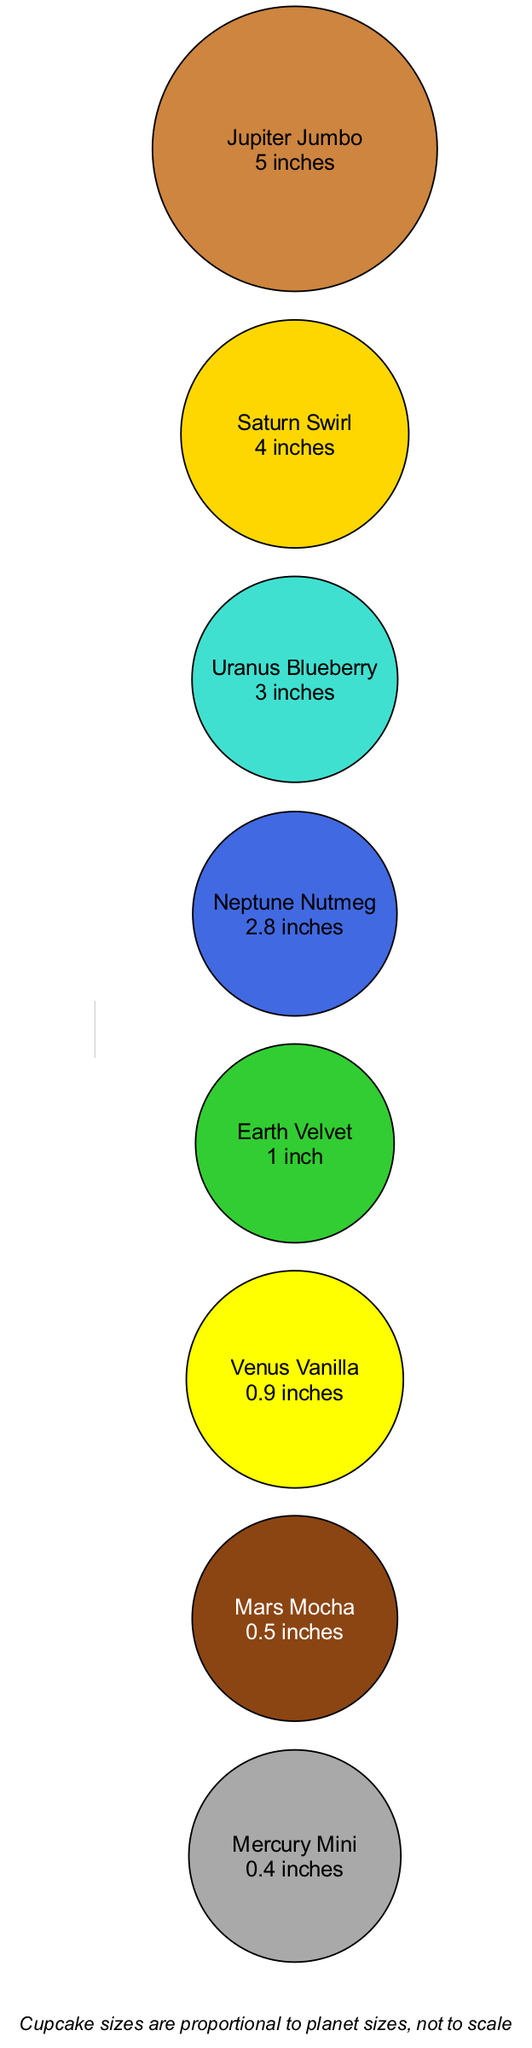What is the size of the largest cupcake? The largest cupcake is represented by "Jupiter Jumbo", which has a size of "5 inches" as stated in the diagram.
Answer: 5 inches Which cupcake has the blue frosting? The cupcake with blue frosting is "Uranus Blueberry", as described in the element details of the diagram.
Answer: Uranus Blueberry How many cupcakes are described in the diagram? Counting the elements listed in the diagram, there are a total of 8 different cupcakes, each representing a planet in the solar system.
Answer: 8 Which cupcake has the smallest size? The size of the smallest cupcake is "Mercury Mini" at "0.4 inches", making it the least in size amongst all the cupcakes presented in the diagram.
Answer: Mercury Mini What color is the "Saturn Swirl" cupcake? The "Saturn Swirl" cupcake is described with a vanilla flavor and has ring-shaped icing, which is indicative of the flavors represented.
Answer: Vanilla Which cupcake represents the third largest planet? The third largest cupcake is "Uranus Blueberry," which is sized at "3 inches". Upon sorting by size, it falls in the third position.
Answer: Uranus Blueberry Which planet is associated with the reddish-brown cupcake? The reddish-brown cupcake is associated with "Mars Mocha," as indicated in its description in the data.
Answer: Mars Mocha What is the average size of all cupcakes in the diagram? To find the average size, we sum all the sizes: 5 + 4 + 3 + 2.8 + 1 + 0.9 + 0.5 + 0.4 = 18.6 inches and divide by 8 cupcakes, which gives us an average of 2.325 inches.
Answer: 2.325 inches 